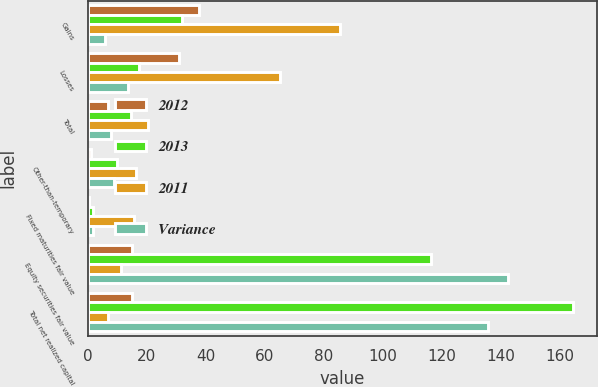Convert chart to OTSL. <chart><loc_0><loc_0><loc_500><loc_500><stacked_bar_chart><ecel><fcel>Gains<fcel>Losses<fcel>Total<fcel>Other-than-temporary<fcel>Fixed maturities fair value<fcel>Equity securities fair value<fcel>Total net realized capital<nl><fcel>2012<fcel>37.7<fcel>30.9<fcel>6.8<fcel>1.1<fcel>0.3<fcel>15.1<fcel>15.1<nl><fcel>2013<fcel>31.9<fcel>17.2<fcel>14.7<fcel>10<fcel>1.9<fcel>116.2<fcel>164.4<nl><fcel>2011<fcel>85.5<fcel>65.1<fcel>20.4<fcel>16.2<fcel>15.5<fcel>11.1<fcel>6.9<nl><fcel>Variance<fcel>5.8<fcel>13.7<fcel>7.9<fcel>8.9<fcel>1.6<fcel>142.4<fcel>135.8<nl></chart> 